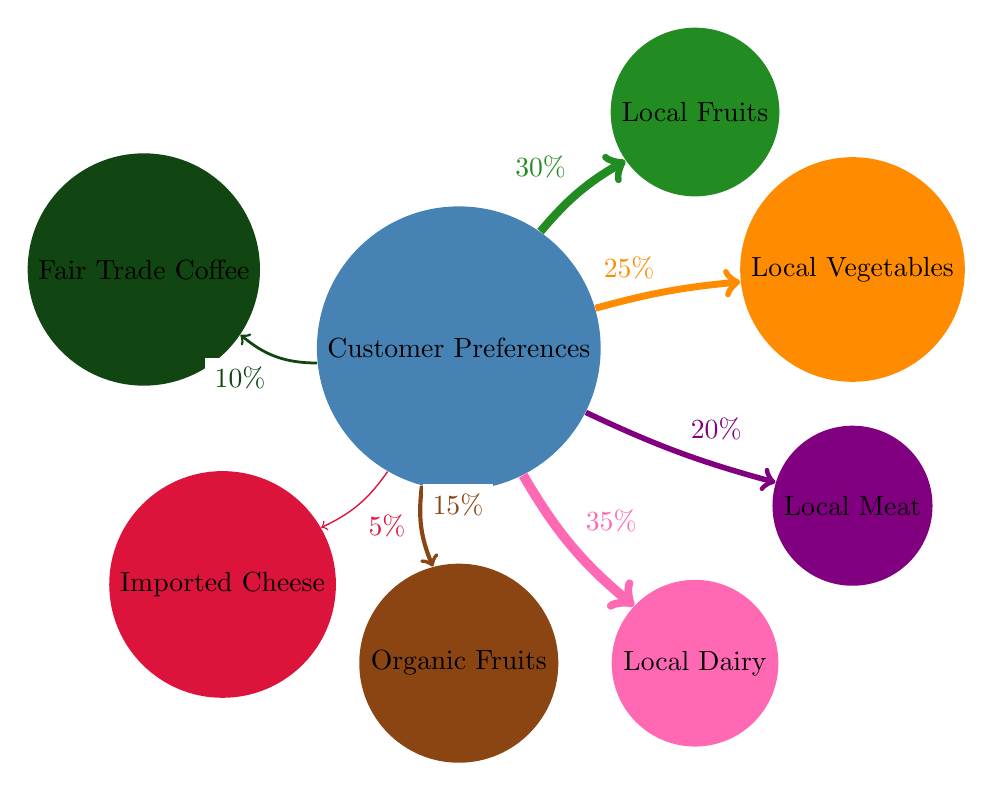What's the percentage preference for Local Dairy? The diagram shows a direct link from "Customer Preferences" to "Local Dairy" with a value of 35%. This indicates the percentage of customers who prefer Local Dairy.
Answer: 35% Which ingredient source has the lowest customer preference? By inspecting the links, the arrow to "Imported Cheese" shows the lowest value of 5%, indicating it has the lowest customer preference among the options.
Answer: Imported Cheese How many total nodes are present in the diagram? The total nodes are counted which includes "Customer Preferences" and the six ingredient sources, giving us a total of 7 nodes in the diagram.
Answer: 7 Which has a higher preference: Local Fruits or Fair Trade Coffee? The diagram shows Local Fruits with a preference of 30% and Fair Trade Coffee with a preference of 10%. Comparing these two values, Local Fruits has a higher preference.
Answer: Local Fruits What is the total percentage of preferences for Local ingredients (Fruits, Vegetables, Meat, Dairy)? To find the total percentage for Local ingredients, sum the values for Local Fruits (30%), Local Vegetables (25%), Local Meat (20%), and Local Dairy (35%). This equals 110%.
Answer: 110% Is the percentage preference for Organic Fruits higher than that for Local Meat? By checking the diagram, Organic Fruits has a preference of 15% while Local Meat has a preference of 20%. Local Meat's percentage is higher.
Answer: No If we focus only on the Local sources, which has the second-highest preference? Looking at the preferences for Local sources: Local Dairy (35%), Local Fruits (30%), Local Vegetables (25%), and Local Meat (20%), the second-highest is Local Fruits with 30%.
Answer: Local Fruits What percentage of customers prefer Organic Fruits? Directly from the diagram, the link from "Customer Preferences" to "Organic Fruits" shows a value of 15%, indicating customer preference.
Answer: 15% 